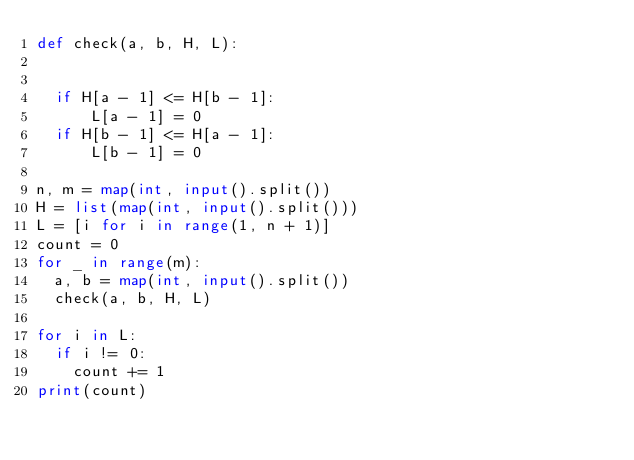Convert code to text. <code><loc_0><loc_0><loc_500><loc_500><_Python_>def check(a, b, H, L):


	if H[a - 1] <= H[b - 1]:
			L[a - 1] = 0
	if H[b - 1] <= H[a - 1]:
			L[b - 1] = 0
	
n, m = map(int, input().split())
H = list(map(int, input().split()))
L = [i for i in range(1, n + 1)]
count = 0
for _ in range(m):
	a, b = map(int, input().split())
	check(a, b, H, L)

for i in L:
	if i != 0:
		count += 1
print(count) 
</code> 